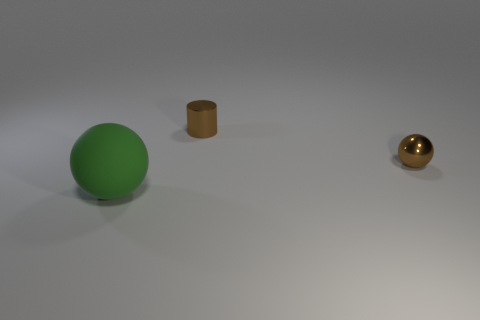Add 3 shiny balls. How many objects exist? 6 Subtract all spheres. How many objects are left? 1 Add 1 big green objects. How many big green objects are left? 2 Add 1 cyan cylinders. How many cyan cylinders exist? 1 Subtract 0 blue cylinders. How many objects are left? 3 Subtract all gray matte cylinders. Subtract all rubber balls. How many objects are left? 2 